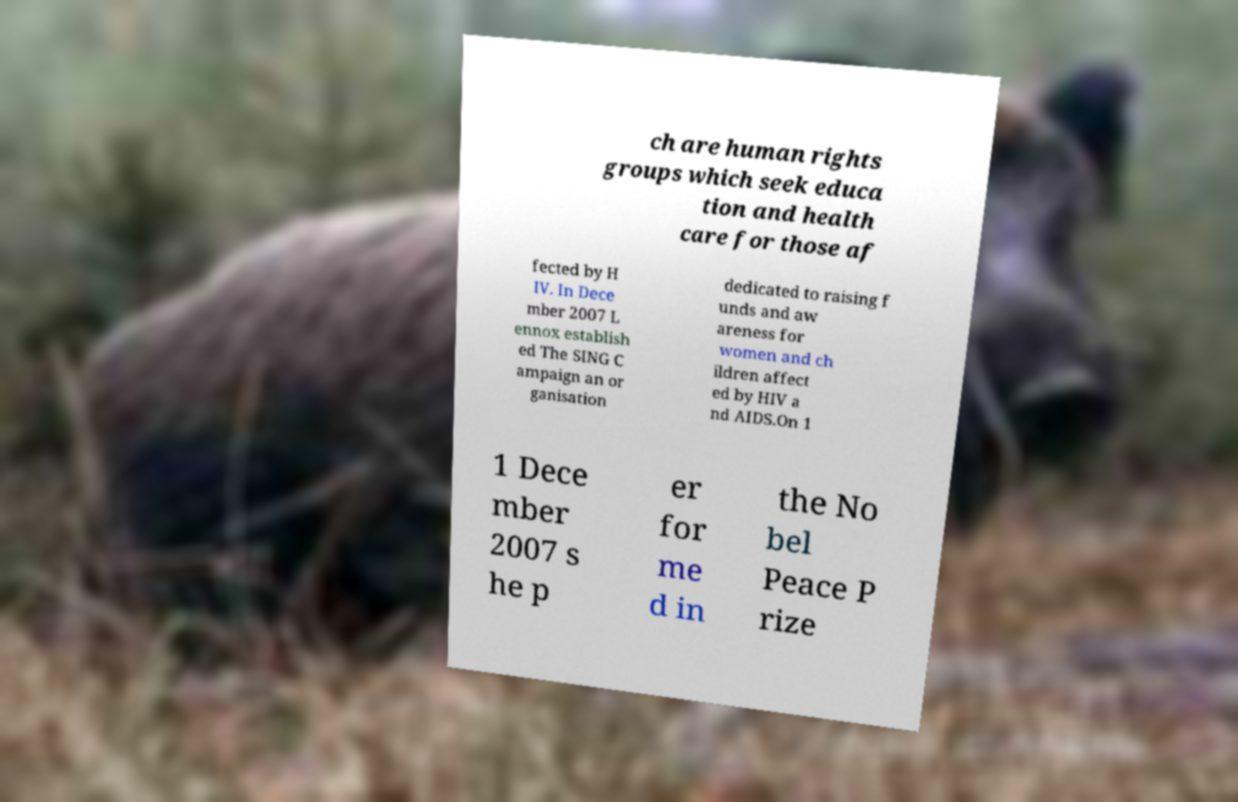Could you assist in decoding the text presented in this image and type it out clearly? ch are human rights groups which seek educa tion and health care for those af fected by H IV. In Dece mber 2007 L ennox establish ed The SING C ampaign an or ganisation dedicated to raising f unds and aw areness for women and ch ildren affect ed by HIV a nd AIDS.On 1 1 Dece mber 2007 s he p er for me d in the No bel Peace P rize 